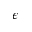Convert formula to latex. <formula><loc_0><loc_0><loc_500><loc_500>\epsilon</formula> 